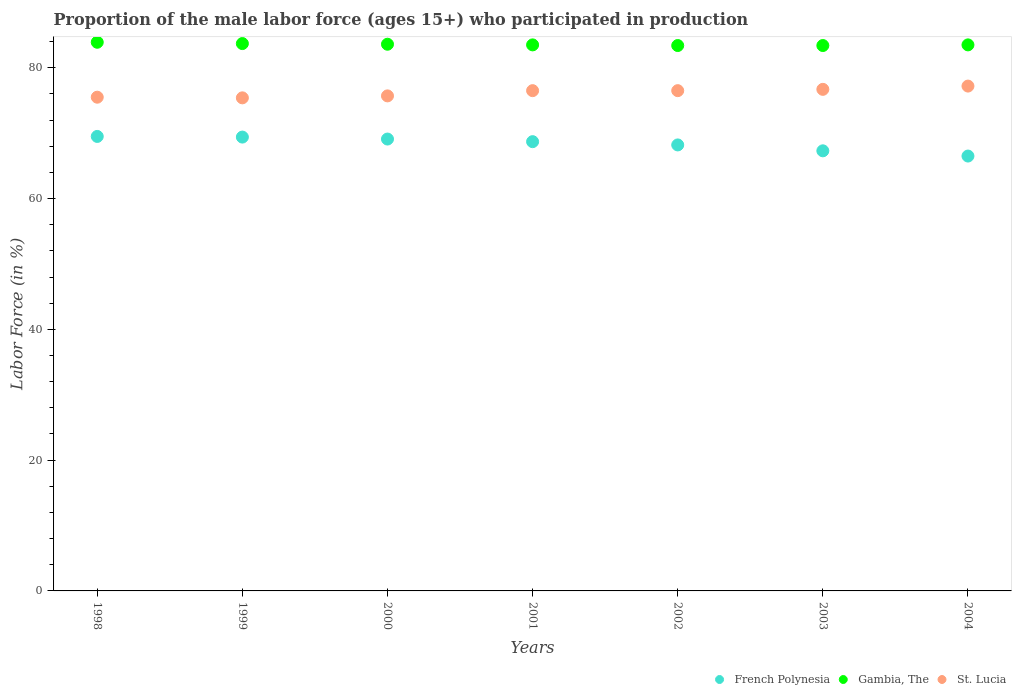Is the number of dotlines equal to the number of legend labels?
Offer a terse response. Yes. What is the proportion of the male labor force who participated in production in Gambia, The in 1998?
Your answer should be very brief. 83.9. Across all years, what is the maximum proportion of the male labor force who participated in production in French Polynesia?
Provide a short and direct response. 69.5. Across all years, what is the minimum proportion of the male labor force who participated in production in Gambia, The?
Offer a very short reply. 83.4. In which year was the proportion of the male labor force who participated in production in St. Lucia maximum?
Your answer should be compact. 2004. What is the total proportion of the male labor force who participated in production in Gambia, The in the graph?
Offer a very short reply. 585. What is the difference between the proportion of the male labor force who participated in production in French Polynesia in 1999 and that in 2002?
Make the answer very short. 1.2. What is the difference between the proportion of the male labor force who participated in production in St. Lucia in 2002 and the proportion of the male labor force who participated in production in French Polynesia in 2000?
Make the answer very short. 7.4. What is the average proportion of the male labor force who participated in production in St. Lucia per year?
Your answer should be compact. 76.21. In the year 2003, what is the difference between the proportion of the male labor force who participated in production in French Polynesia and proportion of the male labor force who participated in production in St. Lucia?
Your answer should be very brief. -9.4. What is the ratio of the proportion of the male labor force who participated in production in French Polynesia in 1999 to that in 2002?
Make the answer very short. 1.02. Is the proportion of the male labor force who participated in production in Gambia, The in 1999 less than that in 2002?
Make the answer very short. No. What is the difference between the highest and the second highest proportion of the male labor force who participated in production in St. Lucia?
Keep it short and to the point. 0.5. In how many years, is the proportion of the male labor force who participated in production in St. Lucia greater than the average proportion of the male labor force who participated in production in St. Lucia taken over all years?
Your answer should be compact. 4. Is it the case that in every year, the sum of the proportion of the male labor force who participated in production in St. Lucia and proportion of the male labor force who participated in production in French Polynesia  is greater than the proportion of the male labor force who participated in production in Gambia, The?
Offer a very short reply. Yes. Is the proportion of the male labor force who participated in production in French Polynesia strictly greater than the proportion of the male labor force who participated in production in St. Lucia over the years?
Keep it short and to the point. No. Is the proportion of the male labor force who participated in production in St. Lucia strictly less than the proportion of the male labor force who participated in production in Gambia, The over the years?
Offer a terse response. Yes. How many dotlines are there?
Offer a terse response. 3. How many years are there in the graph?
Give a very brief answer. 7. Are the values on the major ticks of Y-axis written in scientific E-notation?
Ensure brevity in your answer.  No. Does the graph contain grids?
Offer a very short reply. No. Where does the legend appear in the graph?
Offer a very short reply. Bottom right. How are the legend labels stacked?
Ensure brevity in your answer.  Horizontal. What is the title of the graph?
Offer a terse response. Proportion of the male labor force (ages 15+) who participated in production. Does "American Samoa" appear as one of the legend labels in the graph?
Your response must be concise. No. What is the Labor Force (in %) in French Polynesia in 1998?
Offer a terse response. 69.5. What is the Labor Force (in %) in Gambia, The in 1998?
Your answer should be compact. 83.9. What is the Labor Force (in %) of St. Lucia in 1998?
Offer a very short reply. 75.5. What is the Labor Force (in %) of French Polynesia in 1999?
Keep it short and to the point. 69.4. What is the Labor Force (in %) in Gambia, The in 1999?
Provide a short and direct response. 83.7. What is the Labor Force (in %) in St. Lucia in 1999?
Give a very brief answer. 75.4. What is the Labor Force (in %) in French Polynesia in 2000?
Your answer should be very brief. 69.1. What is the Labor Force (in %) of Gambia, The in 2000?
Your answer should be compact. 83.6. What is the Labor Force (in %) of St. Lucia in 2000?
Offer a terse response. 75.7. What is the Labor Force (in %) of French Polynesia in 2001?
Your response must be concise. 68.7. What is the Labor Force (in %) of Gambia, The in 2001?
Offer a very short reply. 83.5. What is the Labor Force (in %) of St. Lucia in 2001?
Keep it short and to the point. 76.5. What is the Labor Force (in %) of French Polynesia in 2002?
Ensure brevity in your answer.  68.2. What is the Labor Force (in %) in Gambia, The in 2002?
Your response must be concise. 83.4. What is the Labor Force (in %) of St. Lucia in 2002?
Ensure brevity in your answer.  76.5. What is the Labor Force (in %) of French Polynesia in 2003?
Keep it short and to the point. 67.3. What is the Labor Force (in %) in Gambia, The in 2003?
Provide a short and direct response. 83.4. What is the Labor Force (in %) of St. Lucia in 2003?
Your response must be concise. 76.7. What is the Labor Force (in %) of French Polynesia in 2004?
Offer a terse response. 66.5. What is the Labor Force (in %) of Gambia, The in 2004?
Your response must be concise. 83.5. What is the Labor Force (in %) of St. Lucia in 2004?
Your answer should be compact. 77.2. Across all years, what is the maximum Labor Force (in %) in French Polynesia?
Offer a very short reply. 69.5. Across all years, what is the maximum Labor Force (in %) in Gambia, The?
Your answer should be very brief. 83.9. Across all years, what is the maximum Labor Force (in %) of St. Lucia?
Ensure brevity in your answer.  77.2. Across all years, what is the minimum Labor Force (in %) of French Polynesia?
Provide a succinct answer. 66.5. Across all years, what is the minimum Labor Force (in %) of Gambia, The?
Give a very brief answer. 83.4. Across all years, what is the minimum Labor Force (in %) in St. Lucia?
Provide a short and direct response. 75.4. What is the total Labor Force (in %) of French Polynesia in the graph?
Provide a short and direct response. 478.7. What is the total Labor Force (in %) of Gambia, The in the graph?
Offer a terse response. 585. What is the total Labor Force (in %) of St. Lucia in the graph?
Offer a very short reply. 533.5. What is the difference between the Labor Force (in %) in French Polynesia in 1998 and that in 2000?
Keep it short and to the point. 0.4. What is the difference between the Labor Force (in %) in St. Lucia in 1998 and that in 2000?
Offer a very short reply. -0.2. What is the difference between the Labor Force (in %) of French Polynesia in 1998 and that in 2001?
Give a very brief answer. 0.8. What is the difference between the Labor Force (in %) in St. Lucia in 1998 and that in 2001?
Ensure brevity in your answer.  -1. What is the difference between the Labor Force (in %) in St. Lucia in 1998 and that in 2002?
Give a very brief answer. -1. What is the difference between the Labor Force (in %) of St. Lucia in 1998 and that in 2003?
Give a very brief answer. -1.2. What is the difference between the Labor Force (in %) of Gambia, The in 1998 and that in 2004?
Offer a very short reply. 0.4. What is the difference between the Labor Force (in %) of Gambia, The in 1999 and that in 2000?
Provide a short and direct response. 0.1. What is the difference between the Labor Force (in %) in St. Lucia in 1999 and that in 2001?
Give a very brief answer. -1.1. What is the difference between the Labor Force (in %) in French Polynesia in 1999 and that in 2003?
Provide a succinct answer. 2.1. What is the difference between the Labor Force (in %) of Gambia, The in 1999 and that in 2003?
Your answer should be compact. 0.3. What is the difference between the Labor Force (in %) of Gambia, The in 1999 and that in 2004?
Ensure brevity in your answer.  0.2. What is the difference between the Labor Force (in %) of St. Lucia in 1999 and that in 2004?
Give a very brief answer. -1.8. What is the difference between the Labor Force (in %) of Gambia, The in 2000 and that in 2001?
Keep it short and to the point. 0.1. What is the difference between the Labor Force (in %) in St. Lucia in 2000 and that in 2001?
Offer a terse response. -0.8. What is the difference between the Labor Force (in %) in French Polynesia in 2000 and that in 2002?
Your answer should be very brief. 0.9. What is the difference between the Labor Force (in %) in St. Lucia in 2000 and that in 2002?
Provide a short and direct response. -0.8. What is the difference between the Labor Force (in %) of St. Lucia in 2000 and that in 2003?
Your answer should be very brief. -1. What is the difference between the Labor Force (in %) of French Polynesia in 2000 and that in 2004?
Provide a succinct answer. 2.6. What is the difference between the Labor Force (in %) of St. Lucia in 2000 and that in 2004?
Provide a succinct answer. -1.5. What is the difference between the Labor Force (in %) in French Polynesia in 2001 and that in 2003?
Make the answer very short. 1.4. What is the difference between the Labor Force (in %) of Gambia, The in 2001 and that in 2003?
Ensure brevity in your answer.  0.1. What is the difference between the Labor Force (in %) in Gambia, The in 2001 and that in 2004?
Provide a succinct answer. 0. What is the difference between the Labor Force (in %) in St. Lucia in 2001 and that in 2004?
Offer a very short reply. -0.7. What is the difference between the Labor Force (in %) of St. Lucia in 2002 and that in 2003?
Your response must be concise. -0.2. What is the difference between the Labor Force (in %) of Gambia, The in 2003 and that in 2004?
Make the answer very short. -0.1. What is the difference between the Labor Force (in %) of St. Lucia in 2003 and that in 2004?
Offer a very short reply. -0.5. What is the difference between the Labor Force (in %) in French Polynesia in 1998 and the Labor Force (in %) in Gambia, The in 1999?
Provide a succinct answer. -14.2. What is the difference between the Labor Force (in %) of Gambia, The in 1998 and the Labor Force (in %) of St. Lucia in 1999?
Offer a terse response. 8.5. What is the difference between the Labor Force (in %) in French Polynesia in 1998 and the Labor Force (in %) in Gambia, The in 2000?
Provide a succinct answer. -14.1. What is the difference between the Labor Force (in %) in Gambia, The in 1998 and the Labor Force (in %) in St. Lucia in 2000?
Provide a succinct answer. 8.2. What is the difference between the Labor Force (in %) in French Polynesia in 1998 and the Labor Force (in %) in St. Lucia in 2001?
Offer a terse response. -7. What is the difference between the Labor Force (in %) in French Polynesia in 1998 and the Labor Force (in %) in Gambia, The in 2002?
Your answer should be compact. -13.9. What is the difference between the Labor Force (in %) of French Polynesia in 1998 and the Labor Force (in %) of St. Lucia in 2002?
Your answer should be compact. -7. What is the difference between the Labor Force (in %) of French Polynesia in 1998 and the Labor Force (in %) of St. Lucia in 2003?
Ensure brevity in your answer.  -7.2. What is the difference between the Labor Force (in %) of French Polynesia in 1998 and the Labor Force (in %) of St. Lucia in 2004?
Make the answer very short. -7.7. What is the difference between the Labor Force (in %) of Gambia, The in 1999 and the Labor Force (in %) of St. Lucia in 2000?
Provide a succinct answer. 8. What is the difference between the Labor Force (in %) of French Polynesia in 1999 and the Labor Force (in %) of Gambia, The in 2001?
Your answer should be very brief. -14.1. What is the difference between the Labor Force (in %) of French Polynesia in 1999 and the Labor Force (in %) of St. Lucia in 2001?
Provide a short and direct response. -7.1. What is the difference between the Labor Force (in %) of Gambia, The in 1999 and the Labor Force (in %) of St. Lucia in 2001?
Your answer should be very brief. 7.2. What is the difference between the Labor Force (in %) of French Polynesia in 1999 and the Labor Force (in %) of St. Lucia in 2002?
Give a very brief answer. -7.1. What is the difference between the Labor Force (in %) of Gambia, The in 1999 and the Labor Force (in %) of St. Lucia in 2002?
Offer a very short reply. 7.2. What is the difference between the Labor Force (in %) of French Polynesia in 1999 and the Labor Force (in %) of St. Lucia in 2003?
Offer a terse response. -7.3. What is the difference between the Labor Force (in %) in French Polynesia in 1999 and the Labor Force (in %) in Gambia, The in 2004?
Your answer should be very brief. -14.1. What is the difference between the Labor Force (in %) in Gambia, The in 1999 and the Labor Force (in %) in St. Lucia in 2004?
Your answer should be very brief. 6.5. What is the difference between the Labor Force (in %) of French Polynesia in 2000 and the Labor Force (in %) of Gambia, The in 2001?
Your answer should be compact. -14.4. What is the difference between the Labor Force (in %) of French Polynesia in 2000 and the Labor Force (in %) of St. Lucia in 2001?
Ensure brevity in your answer.  -7.4. What is the difference between the Labor Force (in %) of Gambia, The in 2000 and the Labor Force (in %) of St. Lucia in 2001?
Ensure brevity in your answer.  7.1. What is the difference between the Labor Force (in %) of French Polynesia in 2000 and the Labor Force (in %) of Gambia, The in 2002?
Your answer should be very brief. -14.3. What is the difference between the Labor Force (in %) of French Polynesia in 2000 and the Labor Force (in %) of Gambia, The in 2003?
Provide a succinct answer. -14.3. What is the difference between the Labor Force (in %) of Gambia, The in 2000 and the Labor Force (in %) of St. Lucia in 2003?
Ensure brevity in your answer.  6.9. What is the difference between the Labor Force (in %) in French Polynesia in 2000 and the Labor Force (in %) in Gambia, The in 2004?
Provide a succinct answer. -14.4. What is the difference between the Labor Force (in %) in French Polynesia in 2001 and the Labor Force (in %) in Gambia, The in 2002?
Make the answer very short. -14.7. What is the difference between the Labor Force (in %) of Gambia, The in 2001 and the Labor Force (in %) of St. Lucia in 2002?
Your answer should be compact. 7. What is the difference between the Labor Force (in %) of French Polynesia in 2001 and the Labor Force (in %) of Gambia, The in 2003?
Your response must be concise. -14.7. What is the difference between the Labor Force (in %) in French Polynesia in 2001 and the Labor Force (in %) in St. Lucia in 2003?
Your response must be concise. -8. What is the difference between the Labor Force (in %) in French Polynesia in 2001 and the Labor Force (in %) in Gambia, The in 2004?
Make the answer very short. -14.8. What is the difference between the Labor Force (in %) of Gambia, The in 2001 and the Labor Force (in %) of St. Lucia in 2004?
Keep it short and to the point. 6.3. What is the difference between the Labor Force (in %) of French Polynesia in 2002 and the Labor Force (in %) of Gambia, The in 2003?
Your response must be concise. -15.2. What is the difference between the Labor Force (in %) of Gambia, The in 2002 and the Labor Force (in %) of St. Lucia in 2003?
Provide a succinct answer. 6.7. What is the difference between the Labor Force (in %) in French Polynesia in 2002 and the Labor Force (in %) in Gambia, The in 2004?
Provide a short and direct response. -15.3. What is the difference between the Labor Force (in %) of Gambia, The in 2002 and the Labor Force (in %) of St. Lucia in 2004?
Offer a terse response. 6.2. What is the difference between the Labor Force (in %) in French Polynesia in 2003 and the Labor Force (in %) in Gambia, The in 2004?
Your answer should be compact. -16.2. What is the difference between the Labor Force (in %) in Gambia, The in 2003 and the Labor Force (in %) in St. Lucia in 2004?
Make the answer very short. 6.2. What is the average Labor Force (in %) of French Polynesia per year?
Your answer should be very brief. 68.39. What is the average Labor Force (in %) in Gambia, The per year?
Offer a terse response. 83.57. What is the average Labor Force (in %) in St. Lucia per year?
Your response must be concise. 76.21. In the year 1998, what is the difference between the Labor Force (in %) in French Polynesia and Labor Force (in %) in Gambia, The?
Your answer should be very brief. -14.4. In the year 1999, what is the difference between the Labor Force (in %) in French Polynesia and Labor Force (in %) in Gambia, The?
Ensure brevity in your answer.  -14.3. In the year 1999, what is the difference between the Labor Force (in %) in Gambia, The and Labor Force (in %) in St. Lucia?
Provide a succinct answer. 8.3. In the year 2000, what is the difference between the Labor Force (in %) of French Polynesia and Labor Force (in %) of Gambia, The?
Your answer should be compact. -14.5. In the year 2000, what is the difference between the Labor Force (in %) of French Polynesia and Labor Force (in %) of St. Lucia?
Give a very brief answer. -6.6. In the year 2000, what is the difference between the Labor Force (in %) of Gambia, The and Labor Force (in %) of St. Lucia?
Offer a terse response. 7.9. In the year 2001, what is the difference between the Labor Force (in %) in French Polynesia and Labor Force (in %) in Gambia, The?
Your answer should be compact. -14.8. In the year 2001, what is the difference between the Labor Force (in %) in French Polynesia and Labor Force (in %) in St. Lucia?
Keep it short and to the point. -7.8. In the year 2001, what is the difference between the Labor Force (in %) of Gambia, The and Labor Force (in %) of St. Lucia?
Provide a short and direct response. 7. In the year 2002, what is the difference between the Labor Force (in %) in French Polynesia and Labor Force (in %) in Gambia, The?
Ensure brevity in your answer.  -15.2. In the year 2003, what is the difference between the Labor Force (in %) of French Polynesia and Labor Force (in %) of Gambia, The?
Give a very brief answer. -16.1. In the year 2003, what is the difference between the Labor Force (in %) in French Polynesia and Labor Force (in %) in St. Lucia?
Ensure brevity in your answer.  -9.4. In the year 2004, what is the difference between the Labor Force (in %) of French Polynesia and Labor Force (in %) of Gambia, The?
Provide a succinct answer. -17. In the year 2004, what is the difference between the Labor Force (in %) of French Polynesia and Labor Force (in %) of St. Lucia?
Your response must be concise. -10.7. In the year 2004, what is the difference between the Labor Force (in %) of Gambia, The and Labor Force (in %) of St. Lucia?
Give a very brief answer. 6.3. What is the ratio of the Labor Force (in %) of French Polynesia in 1998 to that in 1999?
Offer a very short reply. 1. What is the ratio of the Labor Force (in %) in Gambia, The in 1998 to that in 1999?
Keep it short and to the point. 1. What is the ratio of the Labor Force (in %) in Gambia, The in 1998 to that in 2000?
Your response must be concise. 1. What is the ratio of the Labor Force (in %) in French Polynesia in 1998 to that in 2001?
Your answer should be compact. 1.01. What is the ratio of the Labor Force (in %) of Gambia, The in 1998 to that in 2001?
Offer a terse response. 1. What is the ratio of the Labor Force (in %) in St. Lucia in 1998 to that in 2001?
Provide a short and direct response. 0.99. What is the ratio of the Labor Force (in %) of French Polynesia in 1998 to that in 2002?
Make the answer very short. 1.02. What is the ratio of the Labor Force (in %) of Gambia, The in 1998 to that in 2002?
Offer a terse response. 1.01. What is the ratio of the Labor Force (in %) in St. Lucia in 1998 to that in 2002?
Keep it short and to the point. 0.99. What is the ratio of the Labor Force (in %) in French Polynesia in 1998 to that in 2003?
Ensure brevity in your answer.  1.03. What is the ratio of the Labor Force (in %) in Gambia, The in 1998 to that in 2003?
Provide a succinct answer. 1.01. What is the ratio of the Labor Force (in %) in St. Lucia in 1998 to that in 2003?
Provide a short and direct response. 0.98. What is the ratio of the Labor Force (in %) of French Polynesia in 1998 to that in 2004?
Keep it short and to the point. 1.05. What is the ratio of the Labor Force (in %) of Gambia, The in 1998 to that in 2004?
Offer a very short reply. 1. What is the ratio of the Labor Force (in %) in Gambia, The in 1999 to that in 2000?
Offer a very short reply. 1. What is the ratio of the Labor Force (in %) in French Polynesia in 1999 to that in 2001?
Your answer should be very brief. 1.01. What is the ratio of the Labor Force (in %) in St. Lucia in 1999 to that in 2001?
Your answer should be very brief. 0.99. What is the ratio of the Labor Force (in %) of French Polynesia in 1999 to that in 2002?
Give a very brief answer. 1.02. What is the ratio of the Labor Force (in %) of St. Lucia in 1999 to that in 2002?
Make the answer very short. 0.99. What is the ratio of the Labor Force (in %) in French Polynesia in 1999 to that in 2003?
Provide a short and direct response. 1.03. What is the ratio of the Labor Force (in %) in Gambia, The in 1999 to that in 2003?
Ensure brevity in your answer.  1. What is the ratio of the Labor Force (in %) of St. Lucia in 1999 to that in 2003?
Give a very brief answer. 0.98. What is the ratio of the Labor Force (in %) in French Polynesia in 1999 to that in 2004?
Provide a short and direct response. 1.04. What is the ratio of the Labor Force (in %) in Gambia, The in 1999 to that in 2004?
Give a very brief answer. 1. What is the ratio of the Labor Force (in %) of St. Lucia in 1999 to that in 2004?
Provide a short and direct response. 0.98. What is the ratio of the Labor Force (in %) in St. Lucia in 2000 to that in 2001?
Ensure brevity in your answer.  0.99. What is the ratio of the Labor Force (in %) of French Polynesia in 2000 to that in 2002?
Your answer should be compact. 1.01. What is the ratio of the Labor Force (in %) of Gambia, The in 2000 to that in 2002?
Provide a short and direct response. 1. What is the ratio of the Labor Force (in %) of French Polynesia in 2000 to that in 2003?
Offer a terse response. 1.03. What is the ratio of the Labor Force (in %) in Gambia, The in 2000 to that in 2003?
Provide a short and direct response. 1. What is the ratio of the Labor Force (in %) of St. Lucia in 2000 to that in 2003?
Provide a succinct answer. 0.99. What is the ratio of the Labor Force (in %) in French Polynesia in 2000 to that in 2004?
Give a very brief answer. 1.04. What is the ratio of the Labor Force (in %) in Gambia, The in 2000 to that in 2004?
Provide a short and direct response. 1. What is the ratio of the Labor Force (in %) of St. Lucia in 2000 to that in 2004?
Your answer should be compact. 0.98. What is the ratio of the Labor Force (in %) in French Polynesia in 2001 to that in 2002?
Your answer should be compact. 1.01. What is the ratio of the Labor Force (in %) in French Polynesia in 2001 to that in 2003?
Provide a succinct answer. 1.02. What is the ratio of the Labor Force (in %) of Gambia, The in 2001 to that in 2003?
Ensure brevity in your answer.  1. What is the ratio of the Labor Force (in %) of St. Lucia in 2001 to that in 2003?
Provide a short and direct response. 1. What is the ratio of the Labor Force (in %) in French Polynesia in 2001 to that in 2004?
Your answer should be compact. 1.03. What is the ratio of the Labor Force (in %) in Gambia, The in 2001 to that in 2004?
Make the answer very short. 1. What is the ratio of the Labor Force (in %) of St. Lucia in 2001 to that in 2004?
Offer a very short reply. 0.99. What is the ratio of the Labor Force (in %) in French Polynesia in 2002 to that in 2003?
Offer a very short reply. 1.01. What is the ratio of the Labor Force (in %) of St. Lucia in 2002 to that in 2003?
Offer a terse response. 1. What is the ratio of the Labor Force (in %) of French Polynesia in 2002 to that in 2004?
Provide a short and direct response. 1.03. What is the ratio of the Labor Force (in %) in St. Lucia in 2002 to that in 2004?
Your answer should be compact. 0.99. What is the ratio of the Labor Force (in %) of French Polynesia in 2003 to that in 2004?
Give a very brief answer. 1.01. What is the difference between the highest and the lowest Labor Force (in %) of St. Lucia?
Provide a succinct answer. 1.8. 